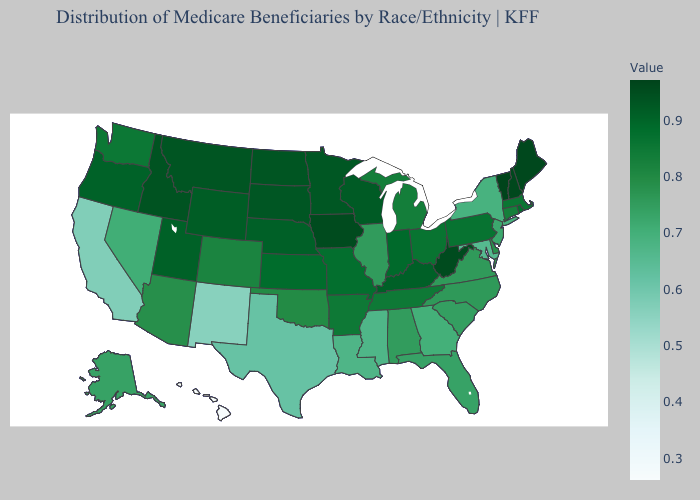Does the map have missing data?
Answer briefly. No. Which states have the highest value in the USA?
Short answer required. Vermont. Which states have the highest value in the USA?
Answer briefly. Vermont. Which states have the lowest value in the USA?
Answer briefly. Hawaii. 